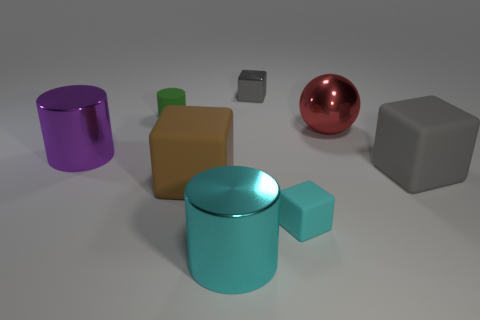Subtract all brown cubes. How many cubes are left? 3 Subtract all metal cylinders. How many cylinders are left? 1 Subtract all spheres. How many objects are left? 7 Subtract 1 balls. How many balls are left? 0 Subtract all purple objects. Subtract all tiny yellow matte things. How many objects are left? 7 Add 8 small cyan objects. How many small cyan objects are left? 9 Add 8 gray rubber things. How many gray rubber things exist? 9 Add 1 tiny shiny things. How many objects exist? 9 Subtract 1 red balls. How many objects are left? 7 Subtract all purple cubes. Subtract all yellow cylinders. How many cubes are left? 4 